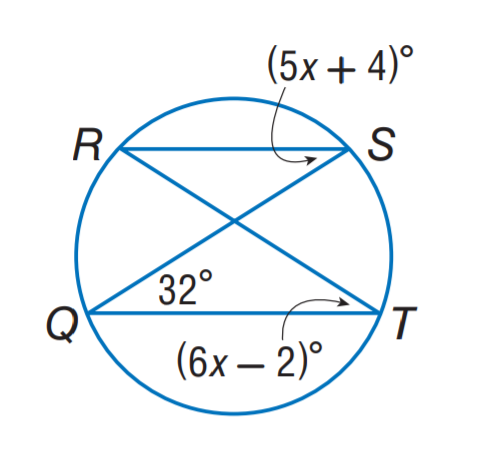Question: Find m \angle R.
Choices:
A. 28
B. 30
C. 32
D. 34
Answer with the letter. Answer: C 